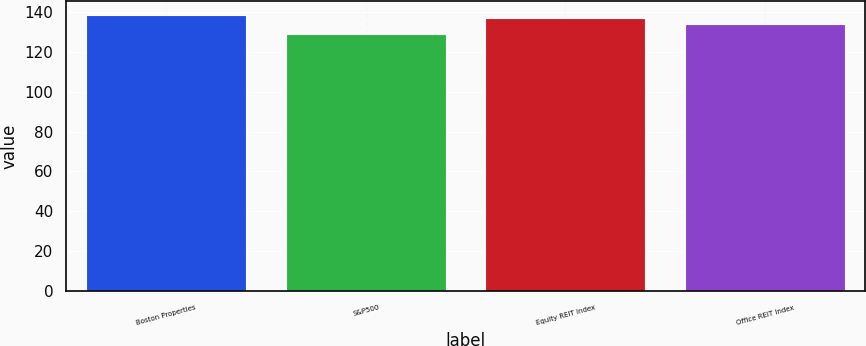Convert chart. <chart><loc_0><loc_0><loc_500><loc_500><bar_chart><fcel>Boston Properties<fcel>S&P500<fcel>Equity REIT Index<fcel>Office REIT Index<nl><fcel>138.5<fcel>128.7<fcel>137.13<fcel>134.01<nl></chart> 